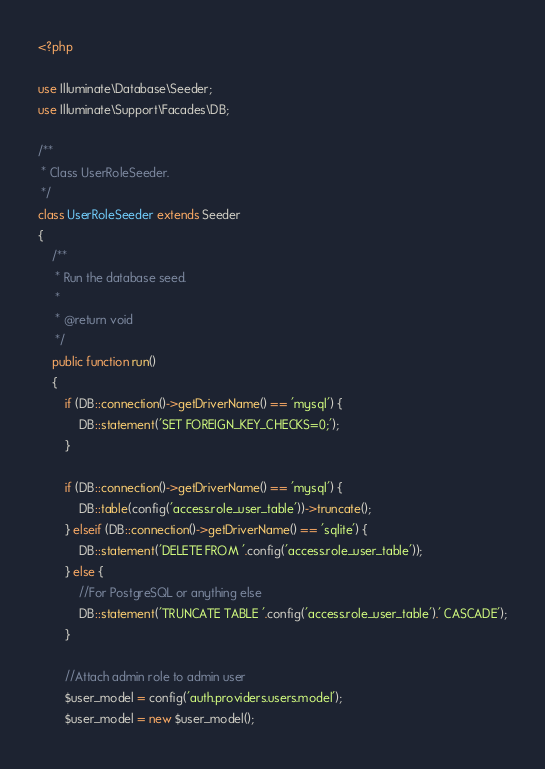Convert code to text. <code><loc_0><loc_0><loc_500><loc_500><_PHP_><?php

use Illuminate\Database\Seeder;
use Illuminate\Support\Facades\DB;

/**
 * Class UserRoleSeeder.
 */
class UserRoleSeeder extends Seeder
{
    /**
     * Run the database seed.
     *
     * @return void
     */
    public function run()
    {
        if (DB::connection()->getDriverName() == 'mysql') {
            DB::statement('SET FOREIGN_KEY_CHECKS=0;');
        }

        if (DB::connection()->getDriverName() == 'mysql') {
            DB::table(config('access.role_user_table'))->truncate();
        } elseif (DB::connection()->getDriverName() == 'sqlite') {
            DB::statement('DELETE FROM '.config('access.role_user_table'));
        } else {
            //For PostgreSQL or anything else
            DB::statement('TRUNCATE TABLE '.config('access.role_user_table').' CASCADE');
        }

        //Attach admin role to admin user
        $user_model = config('auth.providers.users.model');
        $user_model = new $user_model();</code> 